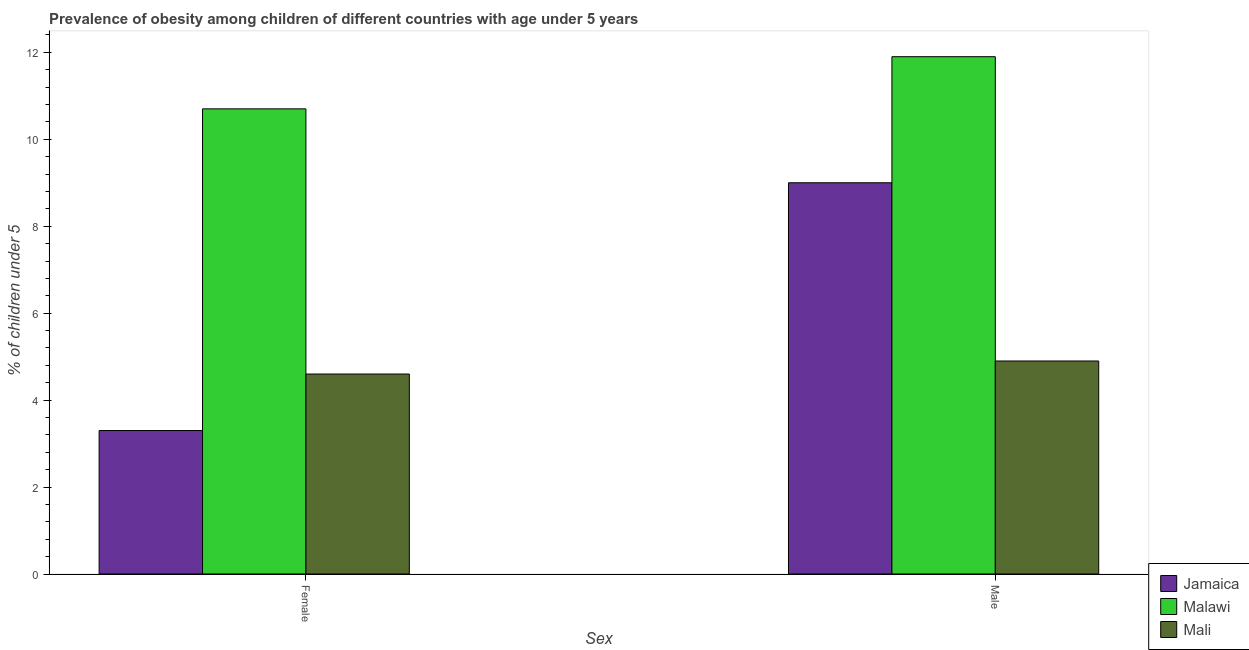How many different coloured bars are there?
Your answer should be compact. 3. How many groups of bars are there?
Your answer should be compact. 2. How many bars are there on the 1st tick from the right?
Provide a succinct answer. 3. What is the label of the 1st group of bars from the left?
Ensure brevity in your answer.  Female. What is the percentage of obese male children in Mali?
Give a very brief answer. 4.9. Across all countries, what is the maximum percentage of obese male children?
Ensure brevity in your answer.  11.9. Across all countries, what is the minimum percentage of obese female children?
Offer a terse response. 3.3. In which country was the percentage of obese male children maximum?
Your answer should be compact. Malawi. In which country was the percentage of obese male children minimum?
Keep it short and to the point. Mali. What is the total percentage of obese female children in the graph?
Provide a succinct answer. 18.6. What is the difference between the percentage of obese female children in Malawi and that in Jamaica?
Provide a succinct answer. 7.4. What is the difference between the percentage of obese male children in Malawi and the percentage of obese female children in Jamaica?
Make the answer very short. 8.6. What is the average percentage of obese female children per country?
Your answer should be very brief. 6.2. What is the difference between the percentage of obese male children and percentage of obese female children in Mali?
Offer a terse response. 0.3. What is the ratio of the percentage of obese male children in Malawi to that in Mali?
Make the answer very short. 2.43. Is the percentage of obese male children in Mali less than that in Malawi?
Give a very brief answer. Yes. What does the 2nd bar from the left in Male represents?
Your answer should be very brief. Malawi. What does the 3rd bar from the right in Female represents?
Provide a succinct answer. Jamaica. How many bars are there?
Your answer should be very brief. 6. Are all the bars in the graph horizontal?
Your response must be concise. No. Where does the legend appear in the graph?
Provide a succinct answer. Bottom right. How are the legend labels stacked?
Ensure brevity in your answer.  Vertical. What is the title of the graph?
Your answer should be compact. Prevalence of obesity among children of different countries with age under 5 years. What is the label or title of the X-axis?
Your answer should be compact. Sex. What is the label or title of the Y-axis?
Keep it short and to the point.  % of children under 5. What is the  % of children under 5 of Jamaica in Female?
Offer a very short reply. 3.3. What is the  % of children under 5 of Malawi in Female?
Your answer should be very brief. 10.7. What is the  % of children under 5 of Mali in Female?
Offer a very short reply. 4.6. What is the  % of children under 5 in Malawi in Male?
Offer a very short reply. 11.9. What is the  % of children under 5 in Mali in Male?
Offer a terse response. 4.9. Across all Sex, what is the maximum  % of children under 5 in Malawi?
Offer a terse response. 11.9. Across all Sex, what is the maximum  % of children under 5 of Mali?
Make the answer very short. 4.9. Across all Sex, what is the minimum  % of children under 5 of Jamaica?
Offer a very short reply. 3.3. Across all Sex, what is the minimum  % of children under 5 of Malawi?
Provide a succinct answer. 10.7. Across all Sex, what is the minimum  % of children under 5 in Mali?
Make the answer very short. 4.6. What is the total  % of children under 5 of Malawi in the graph?
Keep it short and to the point. 22.6. What is the difference between the  % of children under 5 in Jamaica in Female and that in Male?
Offer a terse response. -5.7. What is the difference between the  % of children under 5 of Malawi in Female and that in Male?
Your answer should be compact. -1.2. What is the difference between the  % of children under 5 of Mali in Female and that in Male?
Your answer should be compact. -0.3. What is the difference between the  % of children under 5 of Jamaica in Female and the  % of children under 5 of Malawi in Male?
Provide a short and direct response. -8.6. What is the difference between the  % of children under 5 of Jamaica in Female and the  % of children under 5 of Mali in Male?
Provide a succinct answer. -1.6. What is the average  % of children under 5 of Jamaica per Sex?
Keep it short and to the point. 6.15. What is the average  % of children under 5 in Mali per Sex?
Make the answer very short. 4.75. What is the difference between the  % of children under 5 in Jamaica and  % of children under 5 in Mali in Female?
Your answer should be very brief. -1.3. What is the difference between the  % of children under 5 in Jamaica and  % of children under 5 in Mali in Male?
Provide a succinct answer. 4.1. What is the difference between the  % of children under 5 of Malawi and  % of children under 5 of Mali in Male?
Your answer should be very brief. 7. What is the ratio of the  % of children under 5 of Jamaica in Female to that in Male?
Your answer should be very brief. 0.37. What is the ratio of the  % of children under 5 in Malawi in Female to that in Male?
Offer a terse response. 0.9. What is the ratio of the  % of children under 5 of Mali in Female to that in Male?
Your answer should be compact. 0.94. What is the difference between the highest and the lowest  % of children under 5 in Jamaica?
Make the answer very short. 5.7. What is the difference between the highest and the lowest  % of children under 5 in Malawi?
Ensure brevity in your answer.  1.2. What is the difference between the highest and the lowest  % of children under 5 in Mali?
Your answer should be very brief. 0.3. 